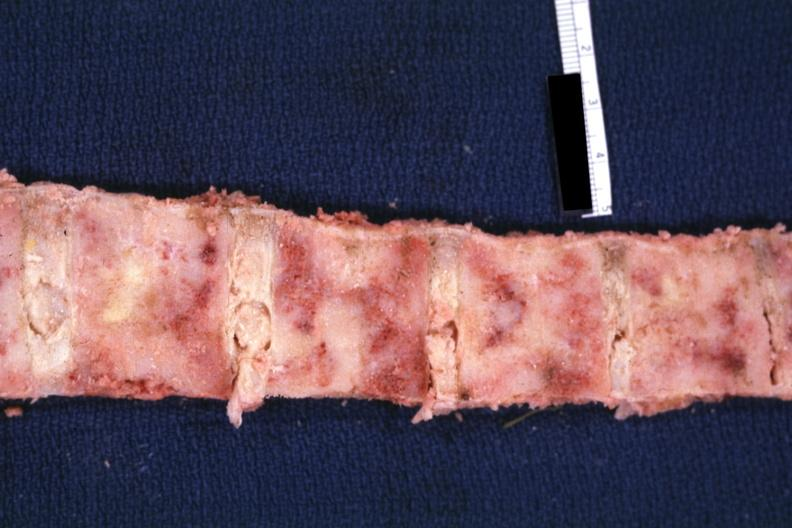does intestine show bone nearly completely filled with tumor primary probably is lung?
Answer the question using a single word or phrase. No 